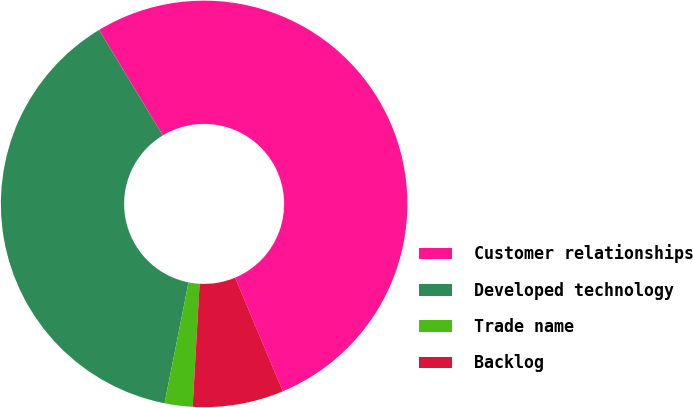Convert chart. <chart><loc_0><loc_0><loc_500><loc_500><pie_chart><fcel>Customer relationships<fcel>Developed technology<fcel>Trade name<fcel>Backlog<nl><fcel>52.31%<fcel>38.24%<fcel>2.22%<fcel>7.23%<nl></chart> 